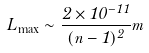Convert formula to latex. <formula><loc_0><loc_0><loc_500><loc_500>L _ { \max } \sim \frac { 2 \times 1 0 ^ { - 1 1 } } { ( n - 1 ) ^ { 2 } } m</formula> 